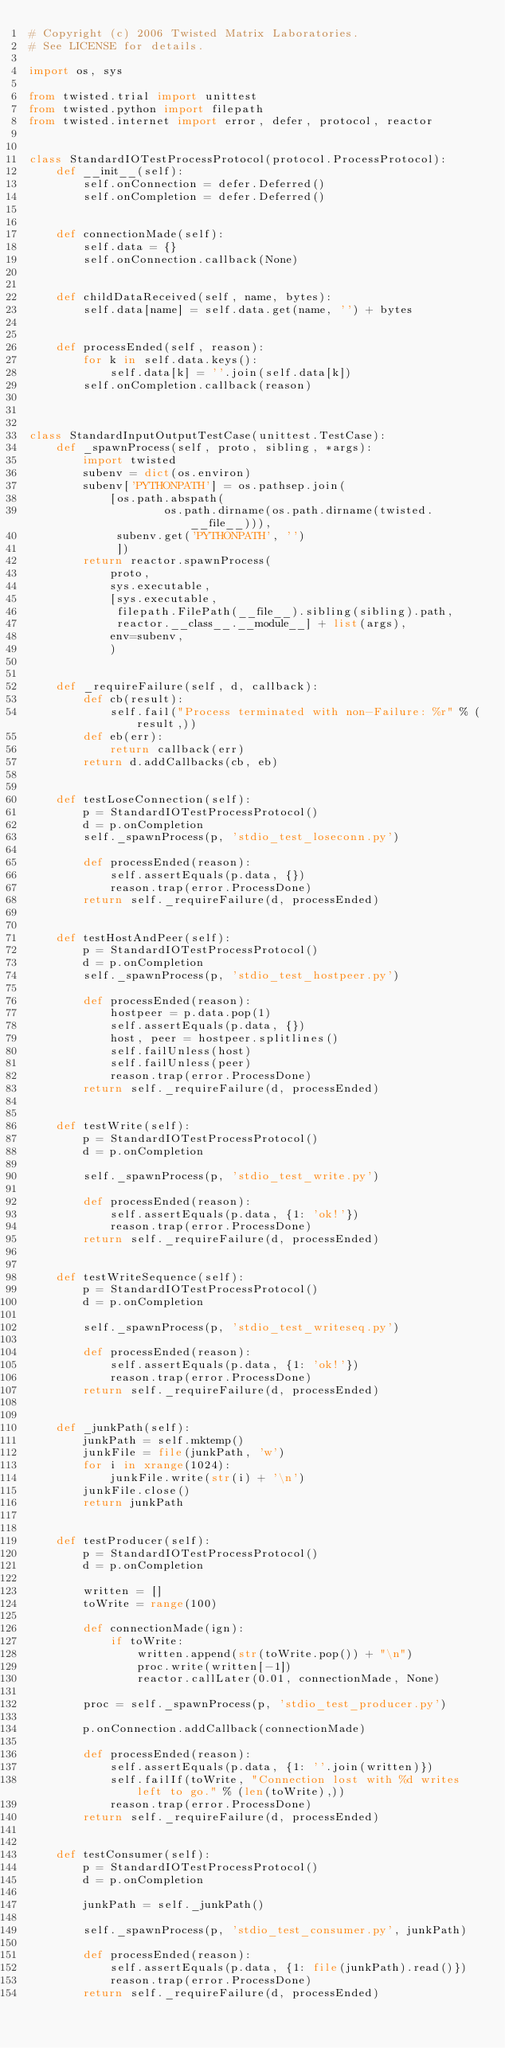<code> <loc_0><loc_0><loc_500><loc_500><_Python_># Copyright (c) 2006 Twisted Matrix Laboratories.
# See LICENSE for details.

import os, sys

from twisted.trial import unittest
from twisted.python import filepath
from twisted.internet import error, defer, protocol, reactor


class StandardIOTestProcessProtocol(protocol.ProcessProtocol):
    def __init__(self):
        self.onConnection = defer.Deferred()
        self.onCompletion = defer.Deferred()


    def connectionMade(self):
        self.data = {}
        self.onConnection.callback(None)


    def childDataReceived(self, name, bytes):
        self.data[name] = self.data.get(name, '') + bytes


    def processEnded(self, reason):
        for k in self.data.keys():
            self.data[k] = ''.join(self.data[k])
        self.onCompletion.callback(reason)



class StandardInputOutputTestCase(unittest.TestCase):
    def _spawnProcess(self, proto, sibling, *args):
        import twisted
        subenv = dict(os.environ)
        subenv['PYTHONPATH'] = os.pathsep.join(
            [os.path.abspath(
                    os.path.dirname(os.path.dirname(twisted.__file__))),
             subenv.get('PYTHONPATH', '')
             ])
        return reactor.spawnProcess(
            proto,
            sys.executable,
            [sys.executable,
             filepath.FilePath(__file__).sibling(sibling).path,
             reactor.__class__.__module__] + list(args),
            env=subenv,
            )


    def _requireFailure(self, d, callback):
        def cb(result):
            self.fail("Process terminated with non-Failure: %r" % (result,))
        def eb(err):
            return callback(err)
        return d.addCallbacks(cb, eb)


    def testLoseConnection(self):
        p = StandardIOTestProcessProtocol()
        d = p.onCompletion
        self._spawnProcess(p, 'stdio_test_loseconn.py')

        def processEnded(reason):
            self.assertEquals(p.data, {})
            reason.trap(error.ProcessDone)
        return self._requireFailure(d, processEnded)


    def testHostAndPeer(self):
        p = StandardIOTestProcessProtocol()
        d = p.onCompletion
        self._spawnProcess(p, 'stdio_test_hostpeer.py')

        def processEnded(reason):
            hostpeer = p.data.pop(1)
            self.assertEquals(p.data, {})
            host, peer = hostpeer.splitlines()
            self.failUnless(host)
            self.failUnless(peer)
            reason.trap(error.ProcessDone)
        return self._requireFailure(d, processEnded)


    def testWrite(self):
        p = StandardIOTestProcessProtocol()
        d = p.onCompletion

        self._spawnProcess(p, 'stdio_test_write.py')

        def processEnded(reason):
            self.assertEquals(p.data, {1: 'ok!'})
            reason.trap(error.ProcessDone)
        return self._requireFailure(d, processEnded)


    def testWriteSequence(self):
        p = StandardIOTestProcessProtocol()
        d = p.onCompletion

        self._spawnProcess(p, 'stdio_test_writeseq.py')

        def processEnded(reason):
            self.assertEquals(p.data, {1: 'ok!'})
            reason.trap(error.ProcessDone)
        return self._requireFailure(d, processEnded)


    def _junkPath(self):
        junkPath = self.mktemp()
        junkFile = file(junkPath, 'w')
        for i in xrange(1024):
            junkFile.write(str(i) + '\n')
        junkFile.close()
        return junkPath


    def testProducer(self):
        p = StandardIOTestProcessProtocol()
        d = p.onCompletion

        written = []
        toWrite = range(100)

        def connectionMade(ign):
            if toWrite:
                written.append(str(toWrite.pop()) + "\n")
                proc.write(written[-1])
                reactor.callLater(0.01, connectionMade, None)

        proc = self._spawnProcess(p, 'stdio_test_producer.py')

        p.onConnection.addCallback(connectionMade)

        def processEnded(reason):
            self.assertEquals(p.data, {1: ''.join(written)})
            self.failIf(toWrite, "Connection lost with %d writes left to go." % (len(toWrite),))
            reason.trap(error.ProcessDone)
        return self._requireFailure(d, processEnded)


    def testConsumer(self):
        p = StandardIOTestProcessProtocol()
        d = p.onCompletion

        junkPath = self._junkPath()

        self._spawnProcess(p, 'stdio_test_consumer.py', junkPath)

        def processEnded(reason):
            self.assertEquals(p.data, {1: file(junkPath).read()})
            reason.trap(error.ProcessDone)
        return self._requireFailure(d, processEnded)
</code> 